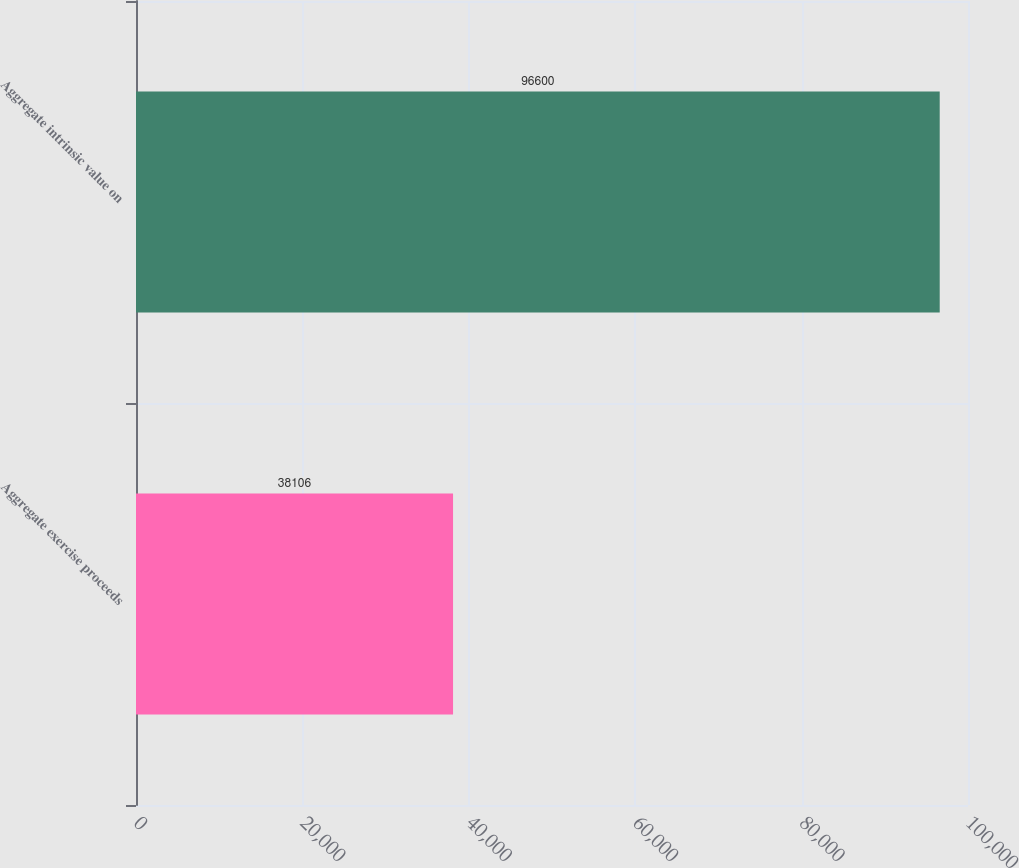<chart> <loc_0><loc_0><loc_500><loc_500><bar_chart><fcel>Aggregate exercise proceeds<fcel>Aggregate intrinsic value on<nl><fcel>38106<fcel>96600<nl></chart> 